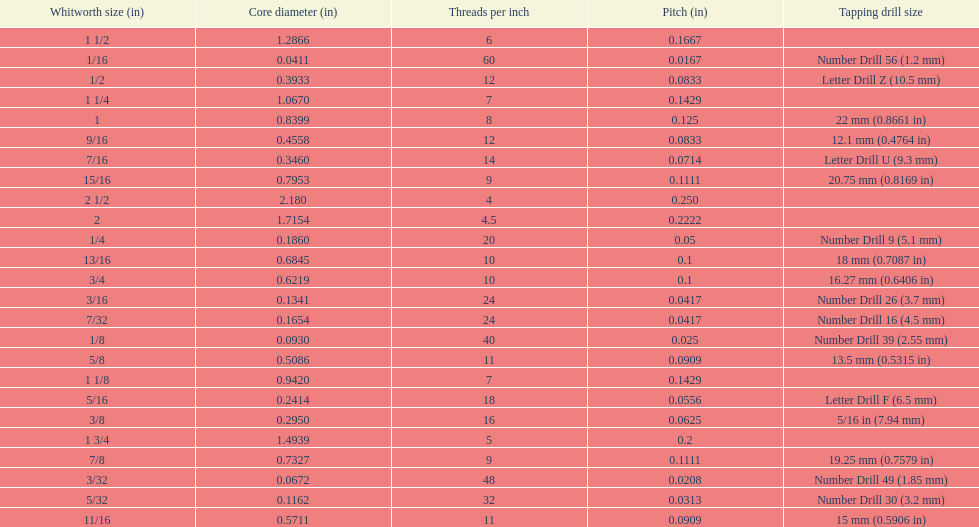What is the next whitworth size (in) below 1/8? 5/32. 